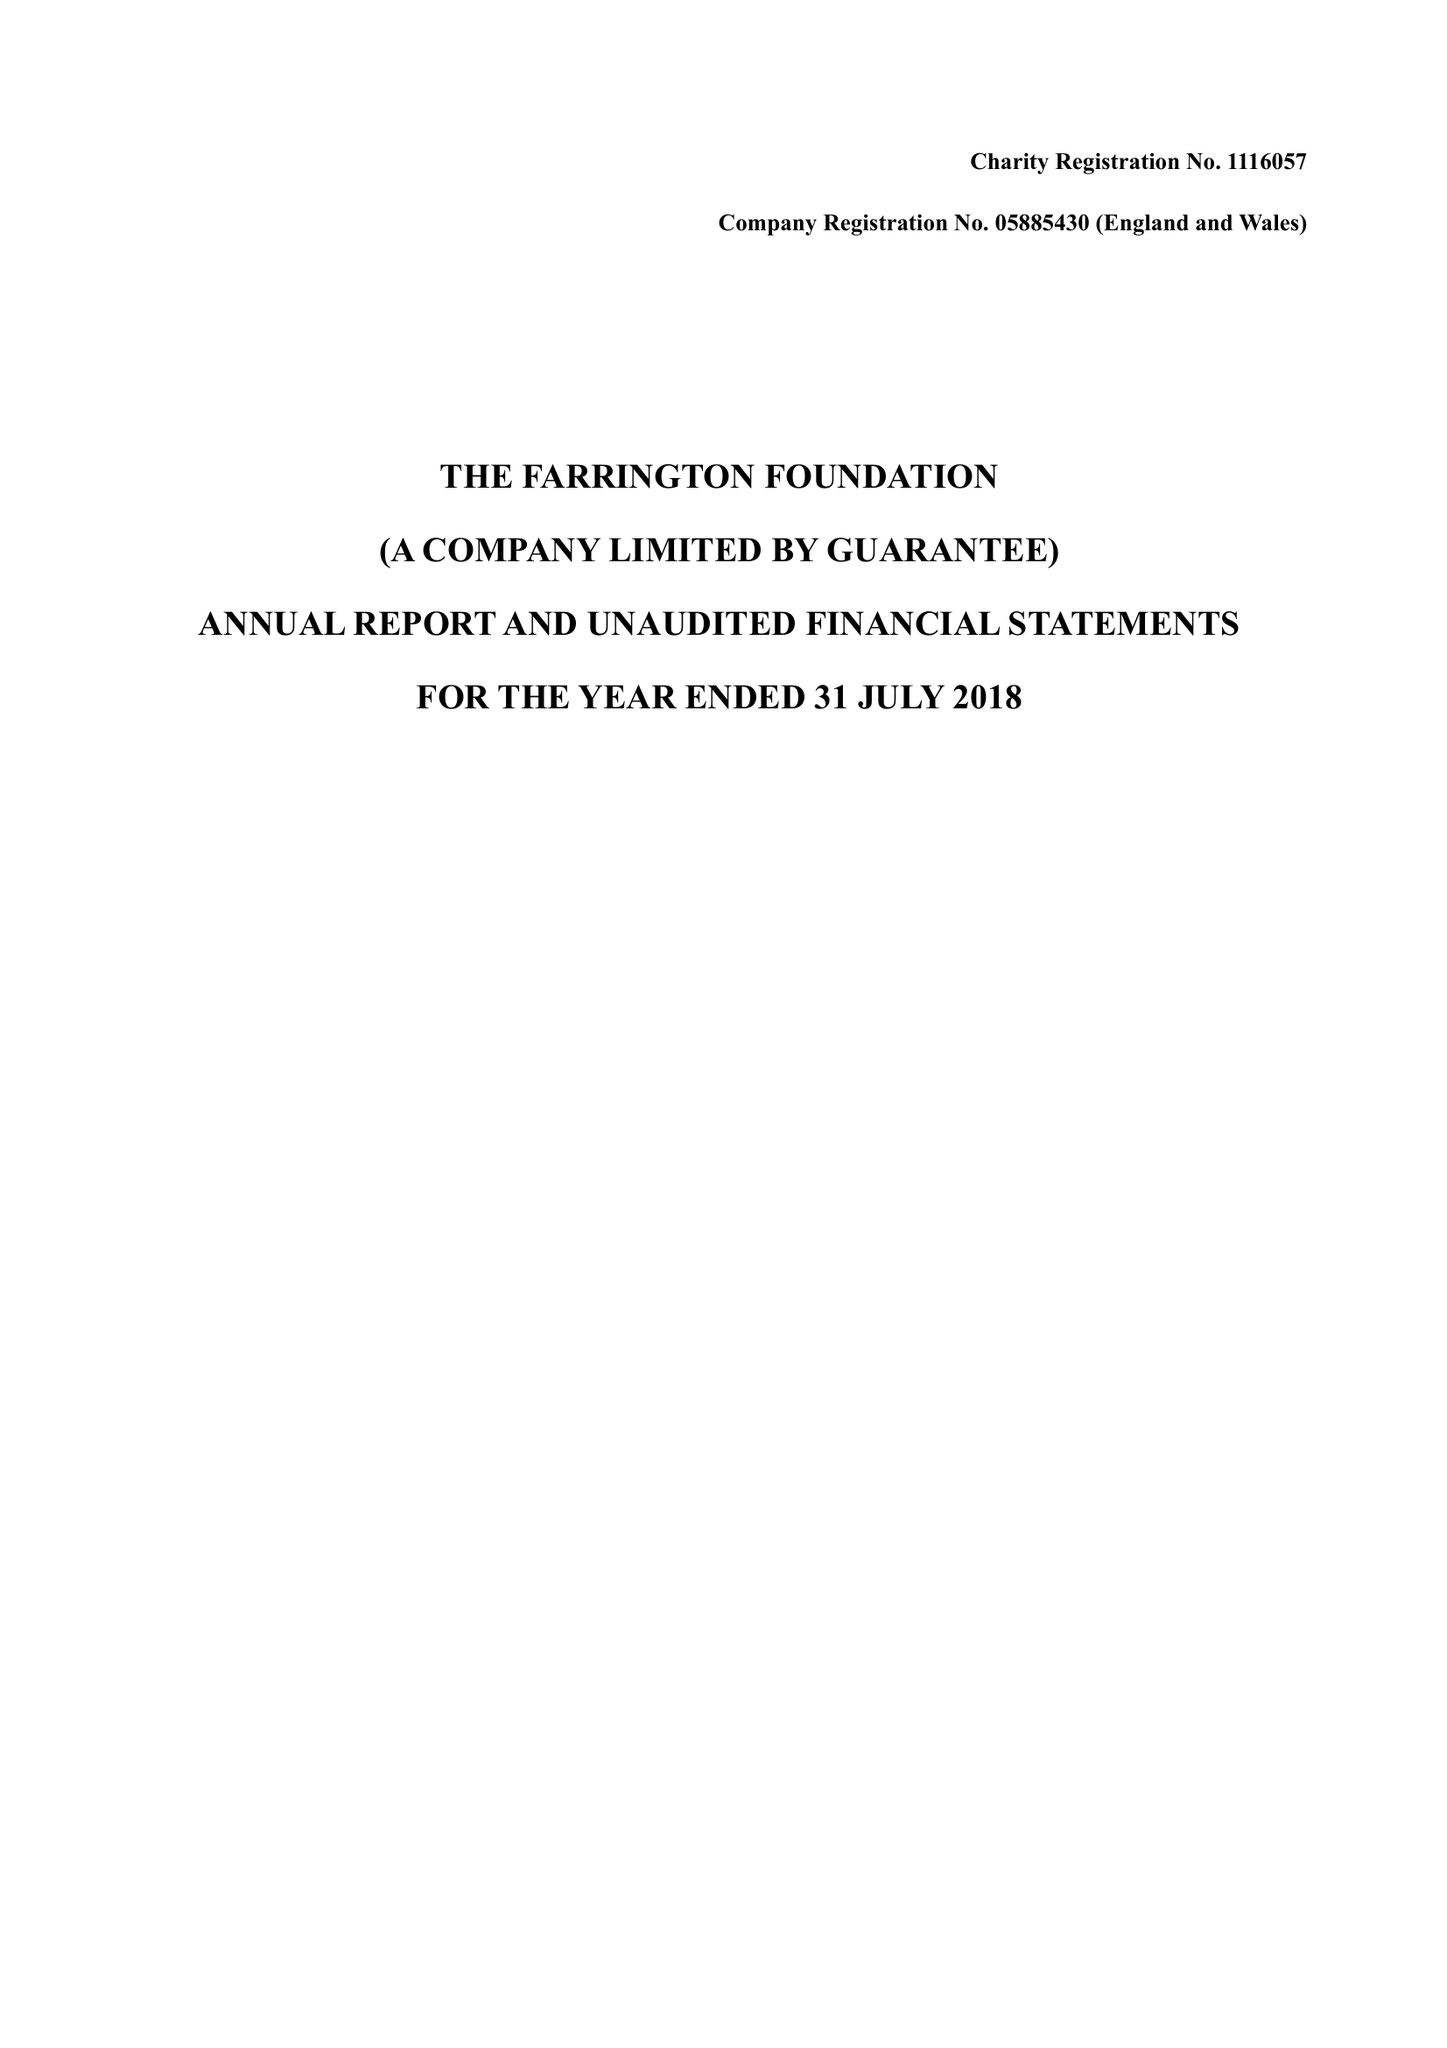What is the value for the charity_number?
Answer the question using a single word or phrase. 1116057 